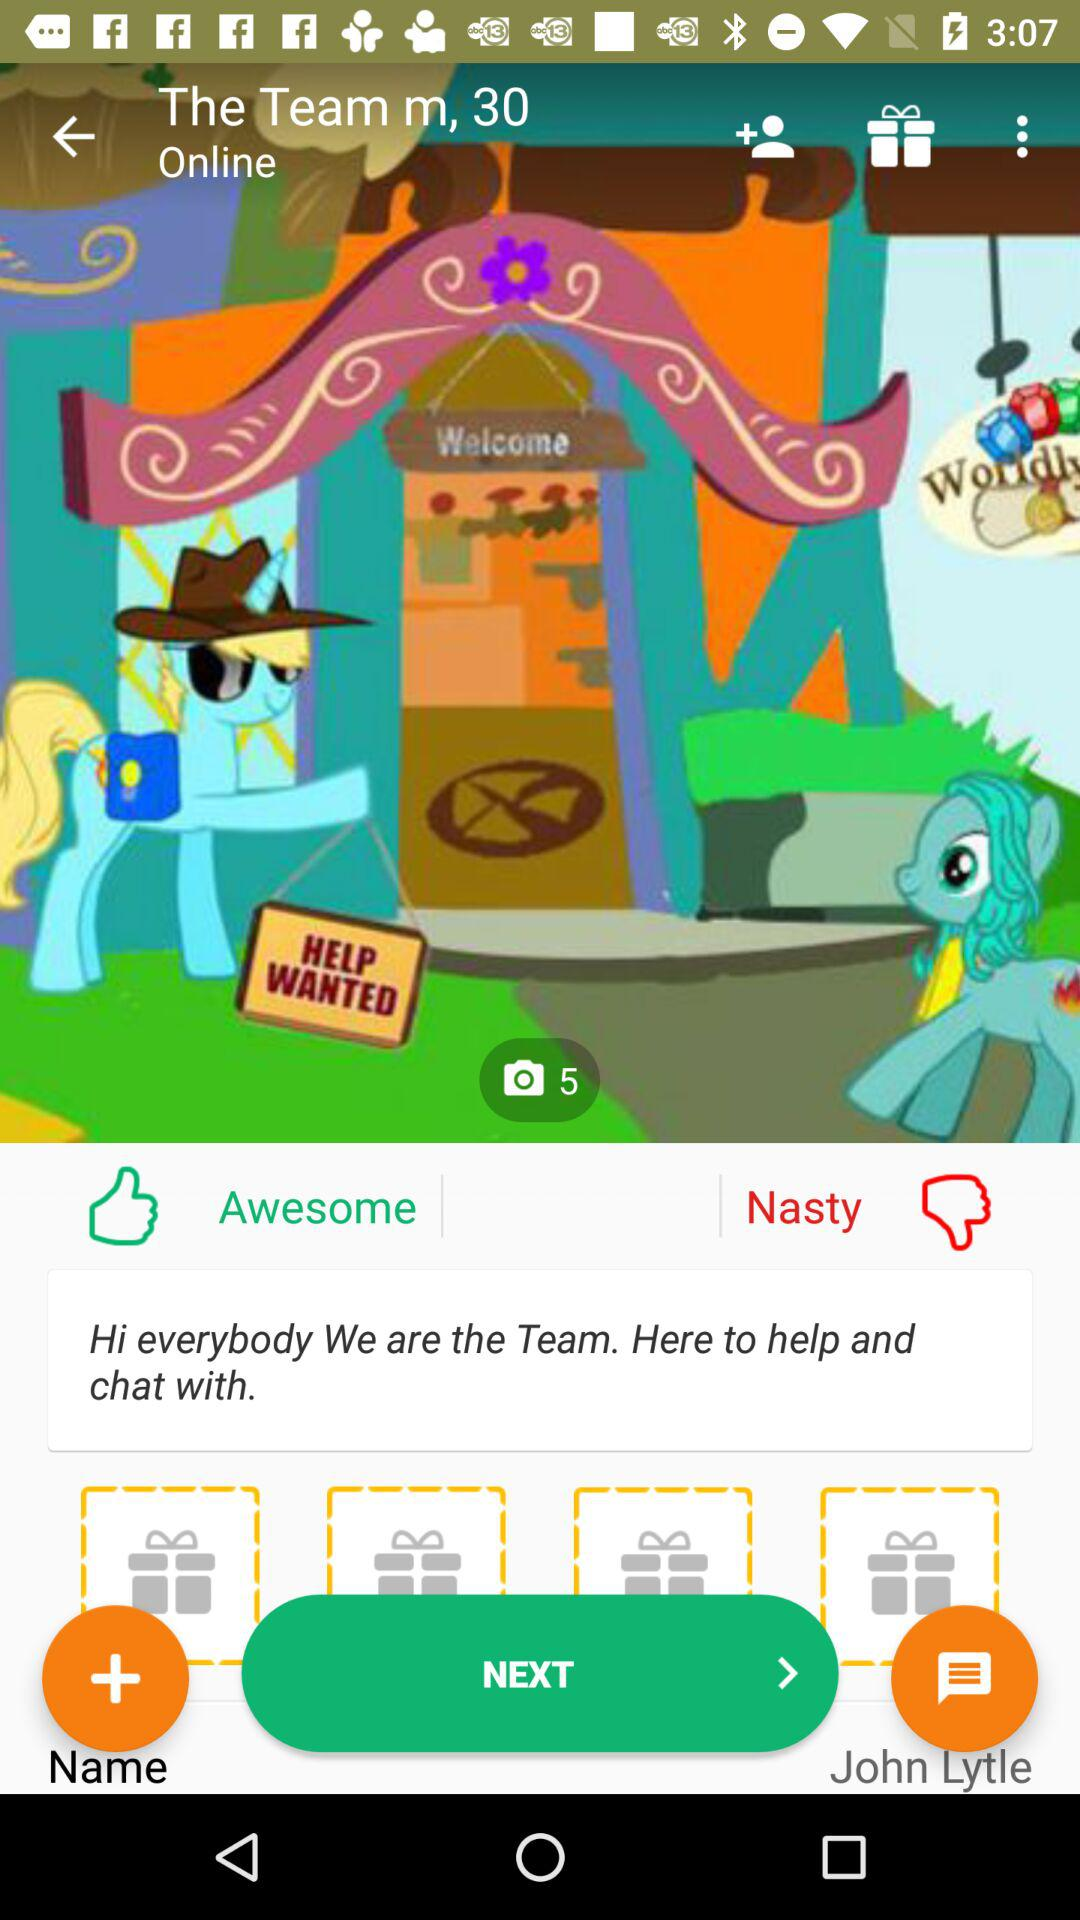What is the active status of "The Team m"? The active status is "online". 